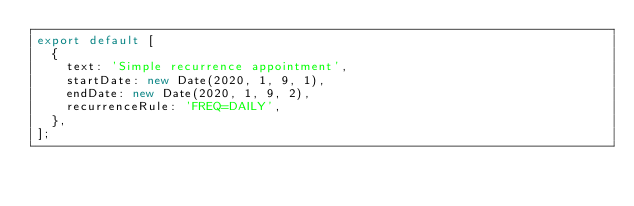<code> <loc_0><loc_0><loc_500><loc_500><_TypeScript_>export default [
  {
    text: 'Simple recurrence appointment',
    startDate: new Date(2020, 1, 9, 1),
    endDate: new Date(2020, 1, 9, 2),
    recurrenceRule: 'FREQ=DAILY',
  },
];
</code> 